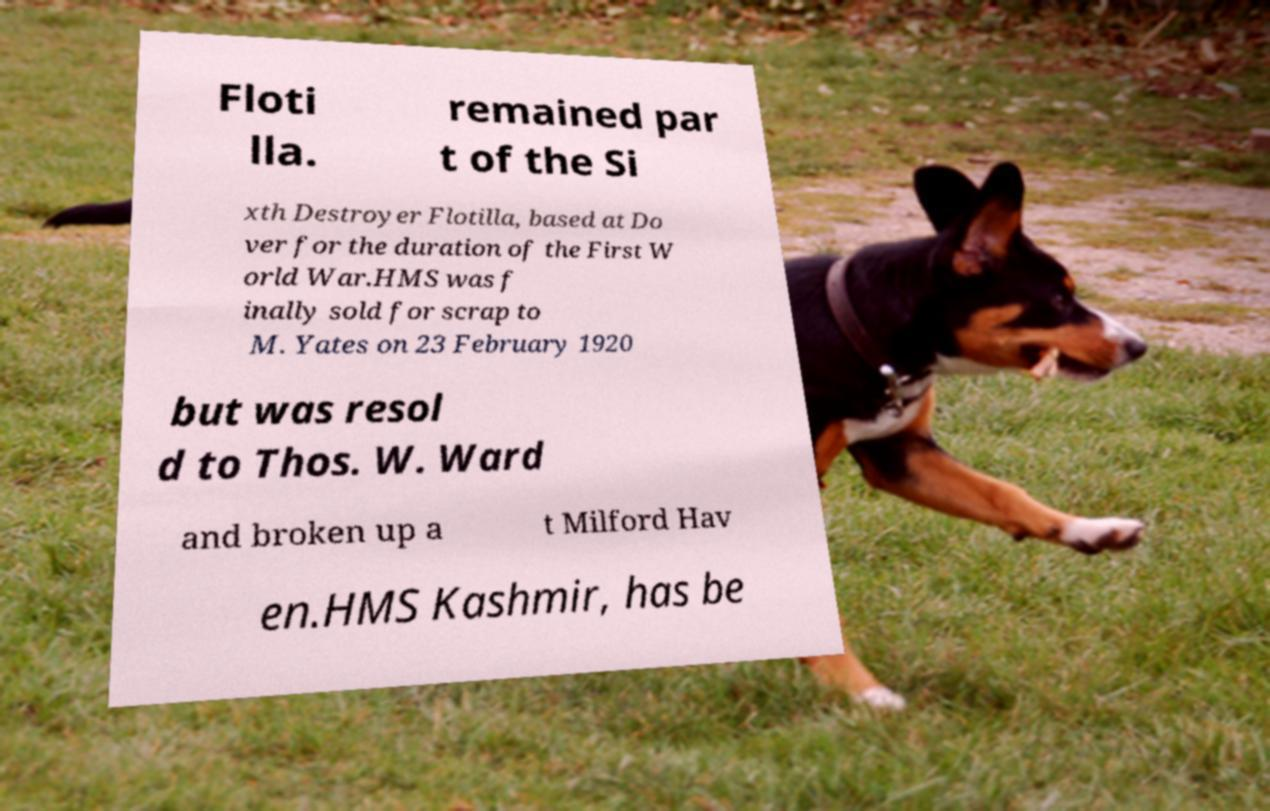Please identify and transcribe the text found in this image. Floti lla. remained par t of the Si xth Destroyer Flotilla, based at Do ver for the duration of the First W orld War.HMS was f inally sold for scrap to M. Yates on 23 February 1920 but was resol d to Thos. W. Ward and broken up a t Milford Hav en.HMS Kashmir, has be 